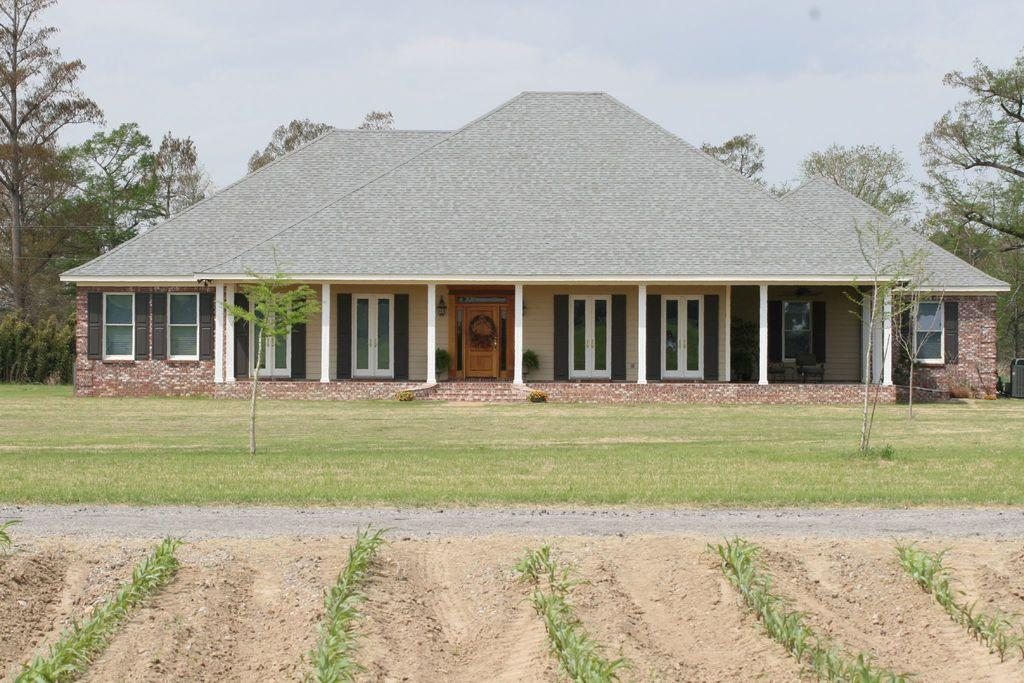What type of vegetation can be seen in the image? There is grass, plants, and trees in the image. What type of structure is visible in the image? There is a house in the image. What is the condition of the sky in the image? The sky is cloudy in the image. How many pigs are visible in the image? There are no pigs present in the image. What invention is being demonstrated in the image? There is no invention being demonstrated in the image. 